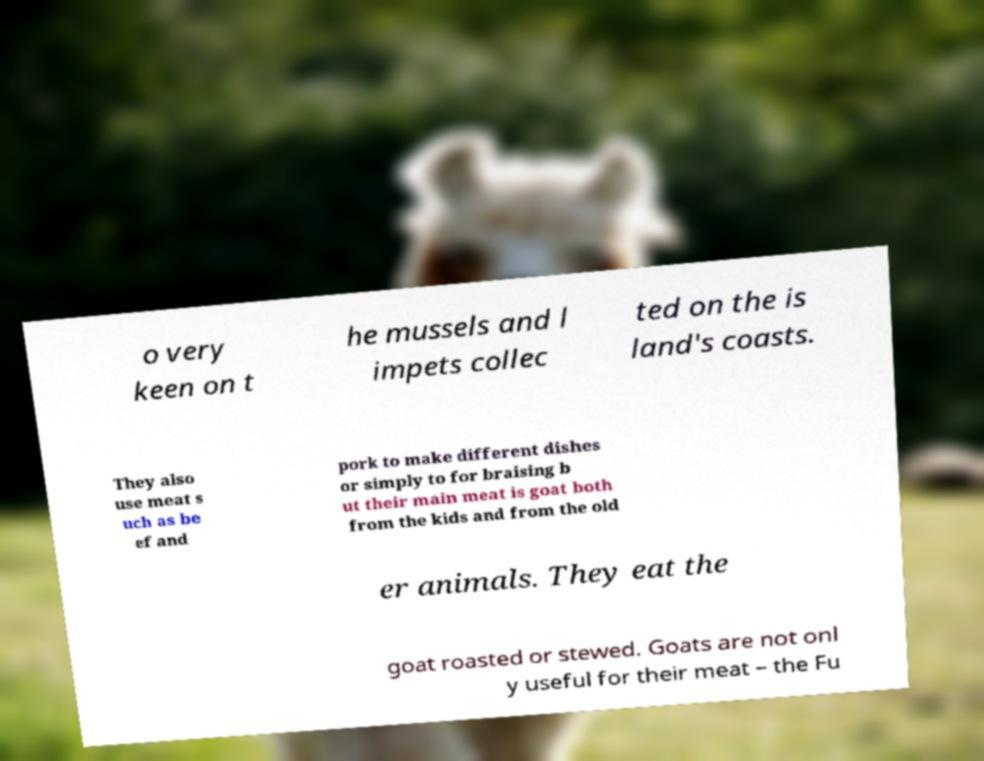There's text embedded in this image that I need extracted. Can you transcribe it verbatim? o very keen on t he mussels and l impets collec ted on the is land's coasts. They also use meat s uch as be ef and pork to make different dishes or simply to for braising b ut their main meat is goat both from the kids and from the old er animals. They eat the goat roasted or stewed. Goats are not onl y useful for their meat – the Fu 